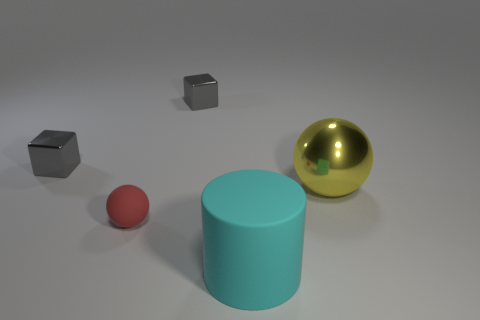Add 1 big yellow objects. How many objects exist? 6 Subtract all blocks. How many objects are left? 3 Add 4 yellow objects. How many yellow objects are left? 5 Add 3 yellow metallic cylinders. How many yellow metallic cylinders exist? 3 Subtract 0 red blocks. How many objects are left? 5 Subtract all big cyan metal cubes. Subtract all large cyan rubber cylinders. How many objects are left? 4 